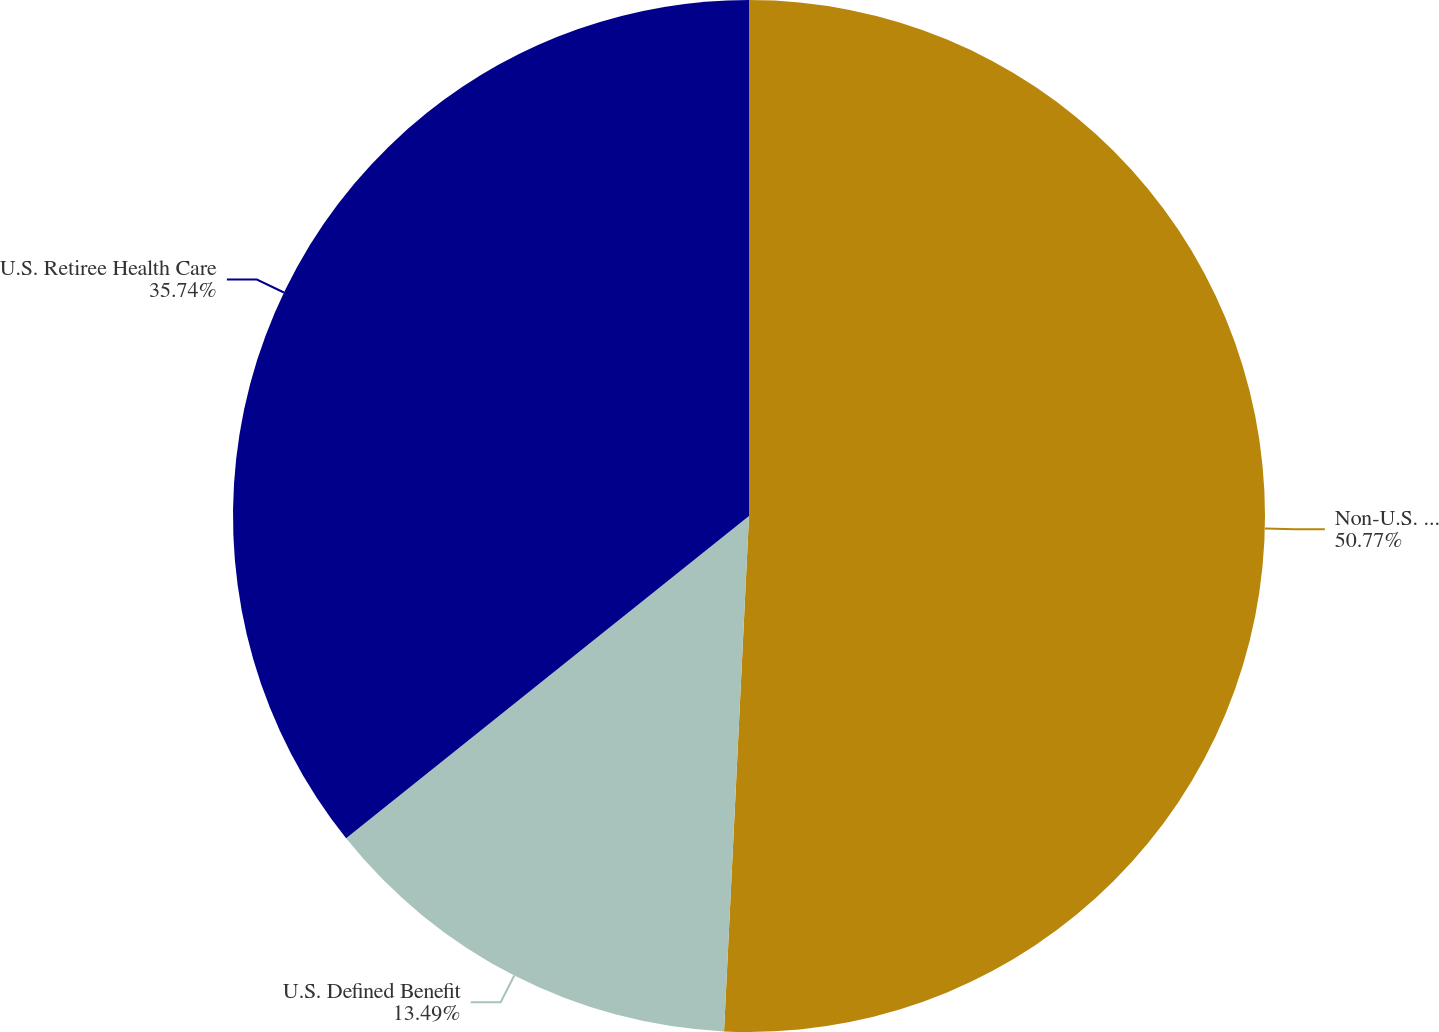<chart> <loc_0><loc_0><loc_500><loc_500><pie_chart><fcel>Non-U.S. Defined Benefit<fcel>U.S. Defined Benefit<fcel>U.S. Retiree Health Care<nl><fcel>50.77%<fcel>13.49%<fcel>35.74%<nl></chart> 